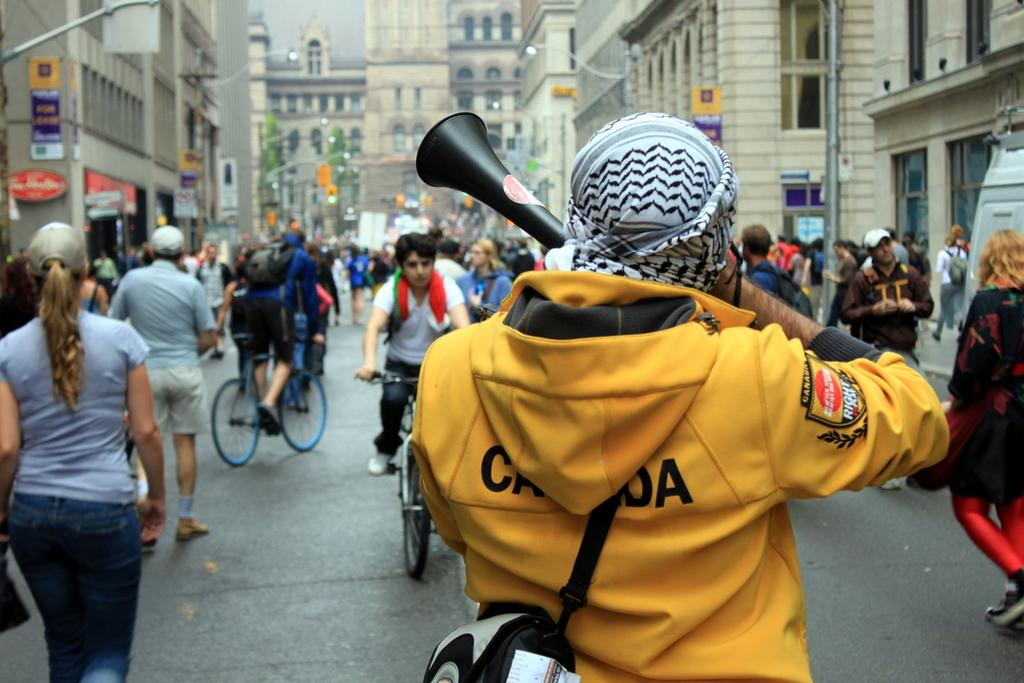How many people are in the image? There are people in the image, specifically two people riding bicycles on the road. What are the people in the image doing? The two people are riding bicycles on the road. What can be seen in the background of the image? In the background of the image, there are buildings, poles, boards, lights, and the sky. Can you describe the setting of the image? The image shows a road with people riding bicycles, and there are various structures and elements in the background, including buildings, poles, boards, lights, and the sky. How many deer are visible in the image? There are no deer present in the image. What type of comfort can be seen in the image? The image does not depict any specific type of comfort. 